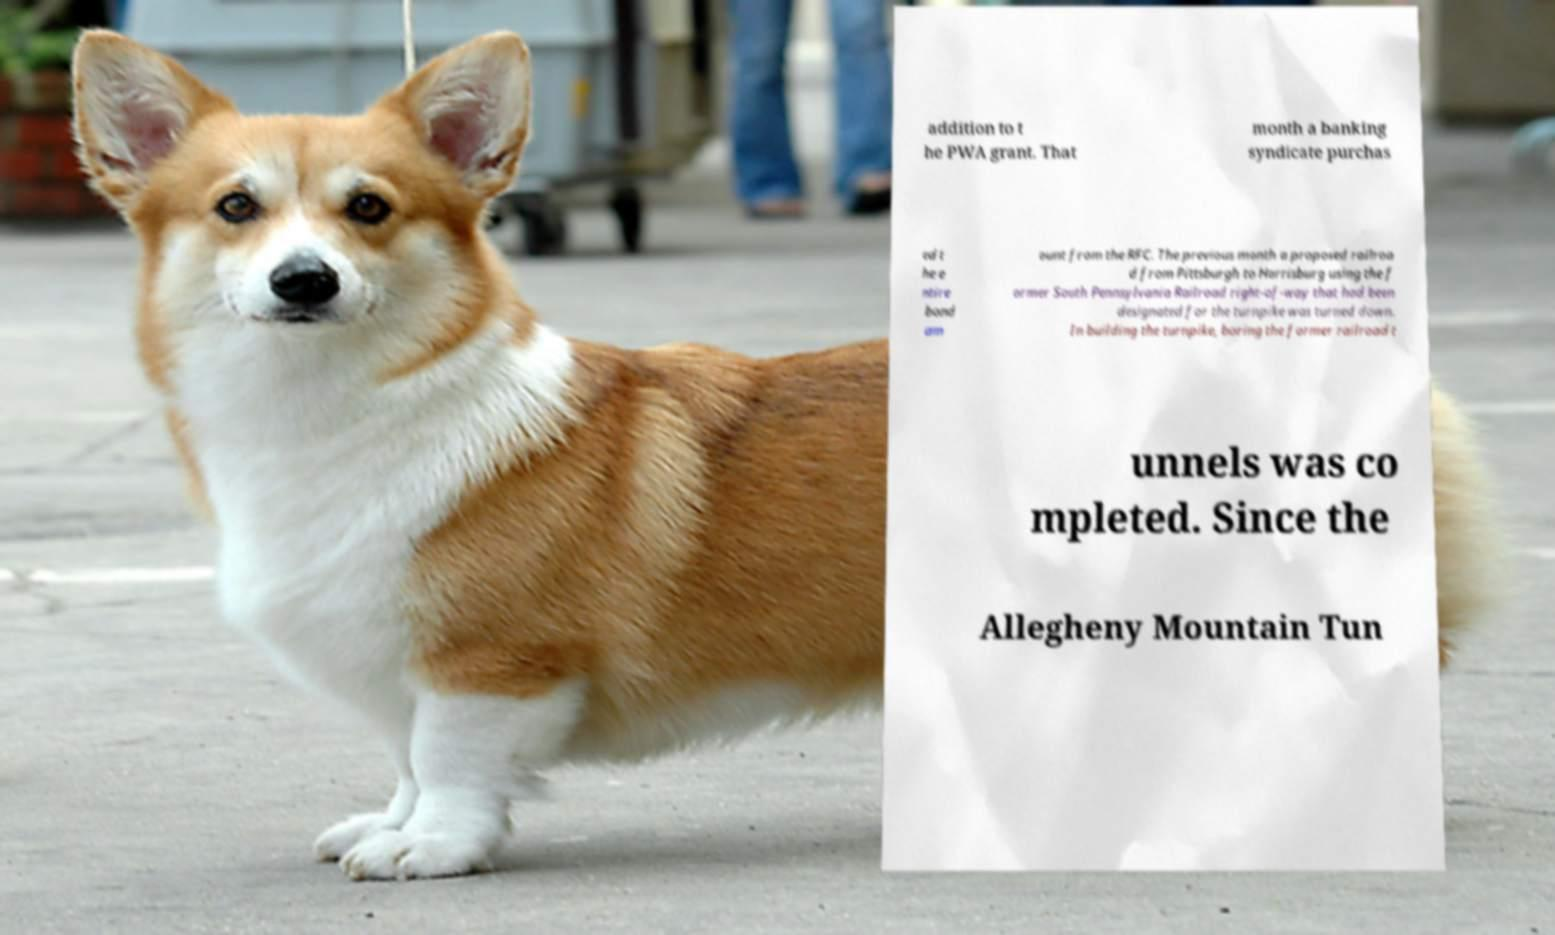Can you accurately transcribe the text from the provided image for me? addition to t he PWA grant. That month a banking syndicate purchas ed t he e ntire bond am ount from the RFC. The previous month a proposed railroa d from Pittsburgh to Harrisburg using the f ormer South Pennsylvania Railroad right-of-way that had been designated for the turnpike was turned down. In building the turnpike, boring the former railroad t unnels was co mpleted. Since the Allegheny Mountain Tun 